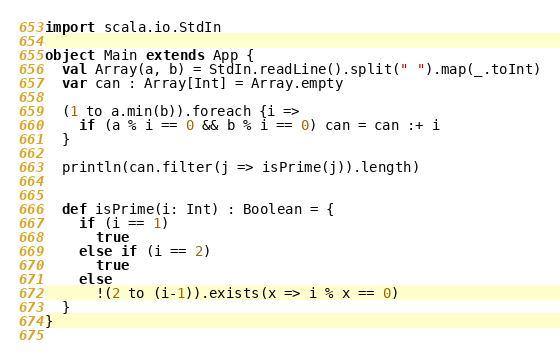Convert code to text. <code><loc_0><loc_0><loc_500><loc_500><_Scala_>import scala.io.StdIn

object Main extends App {
  val Array(a, b) = StdIn.readLine().split(" ").map(_.toInt)
  var can : Array[Int] = Array.empty

  (1 to a.min(b)).foreach {i =>
    if (a % i == 0 && b % i == 0) can = can :+ i
  }

  println(can.filter(j => isPrime(j)).length)
  

  def isPrime(i: Int) : Boolean = {
    if (i == 1)
      true
    else if (i == 2)
      true
    else
      !(2 to (i-1)).exists(x => i % x == 0)
  }
}
  

</code> 